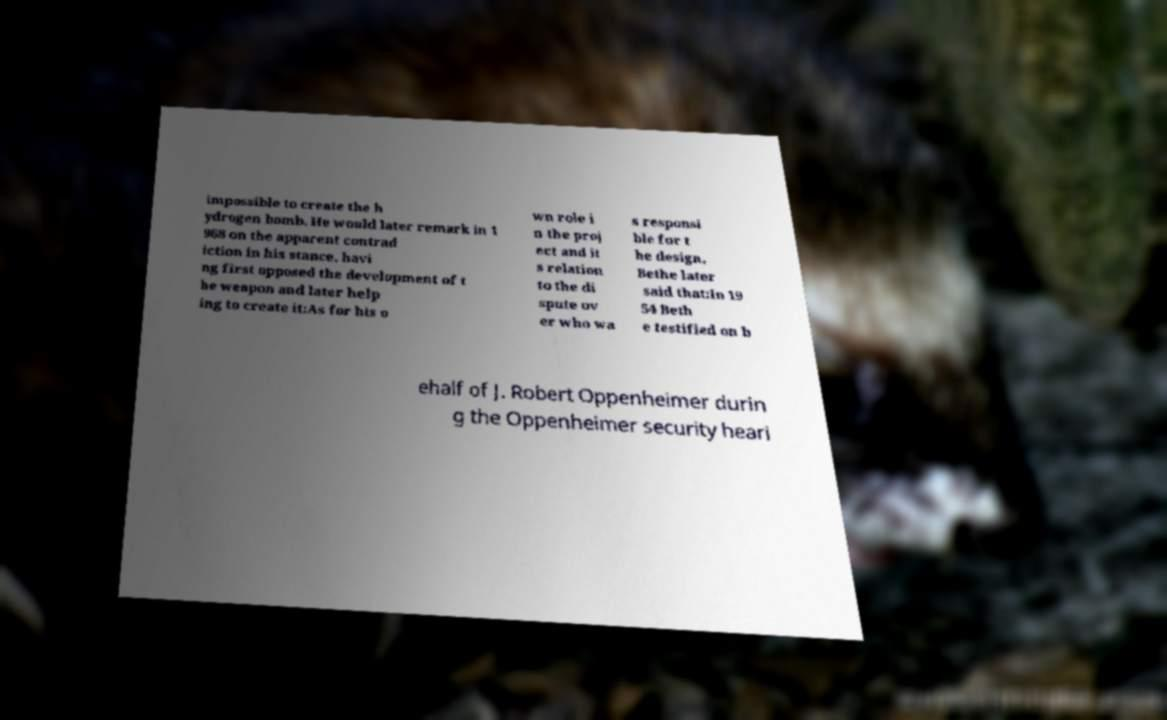There's text embedded in this image that I need extracted. Can you transcribe it verbatim? impossible to create the h ydrogen bomb. He would later remark in 1 968 on the apparent contrad iction in his stance, havi ng first opposed the development of t he weapon and later help ing to create it:As for his o wn role i n the proj ect and it s relation to the di spute ov er who wa s responsi ble for t he design, Bethe later said that:In 19 54 Beth e testified on b ehalf of J. Robert Oppenheimer durin g the Oppenheimer security heari 